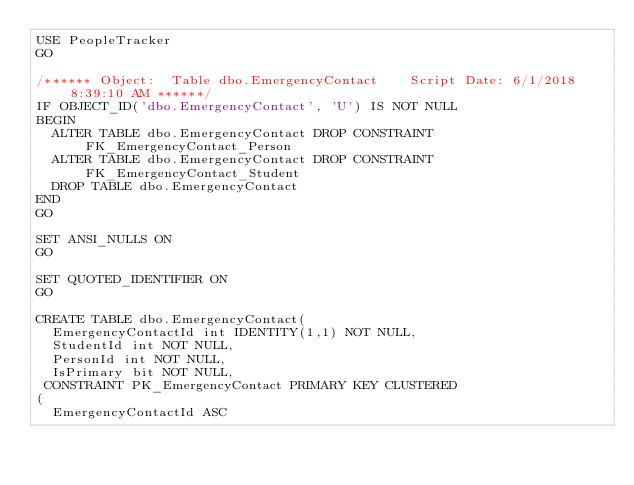Convert code to text. <code><loc_0><loc_0><loc_500><loc_500><_SQL_>USE PeopleTracker
GO

/****** Object:  Table dbo.EmergencyContact    Script Date: 6/1/2018 8:39:10 AM ******/
IF OBJECT_ID('dbo.EmergencyContact', 'U') IS NOT NULL
BEGIN
  ALTER TABLE dbo.EmergencyContact DROP CONSTRAINT FK_EmergencyContact_Person
  ALTER TABLE dbo.EmergencyContact DROP CONSTRAINT FK_EmergencyContact_Student
	DROP TABLE dbo.EmergencyContact
END
GO

SET ANSI_NULLS ON
GO

SET QUOTED_IDENTIFIER ON
GO

CREATE TABLE dbo.EmergencyContact(
	EmergencyContactId int IDENTITY(1,1) NOT NULL,
	StudentId int NOT NULL,
	PersonId int NOT NULL,
	IsPrimary bit NOT NULL,
 CONSTRAINT PK_EmergencyContact PRIMARY KEY CLUSTERED
(
	EmergencyContactId ASC</code> 